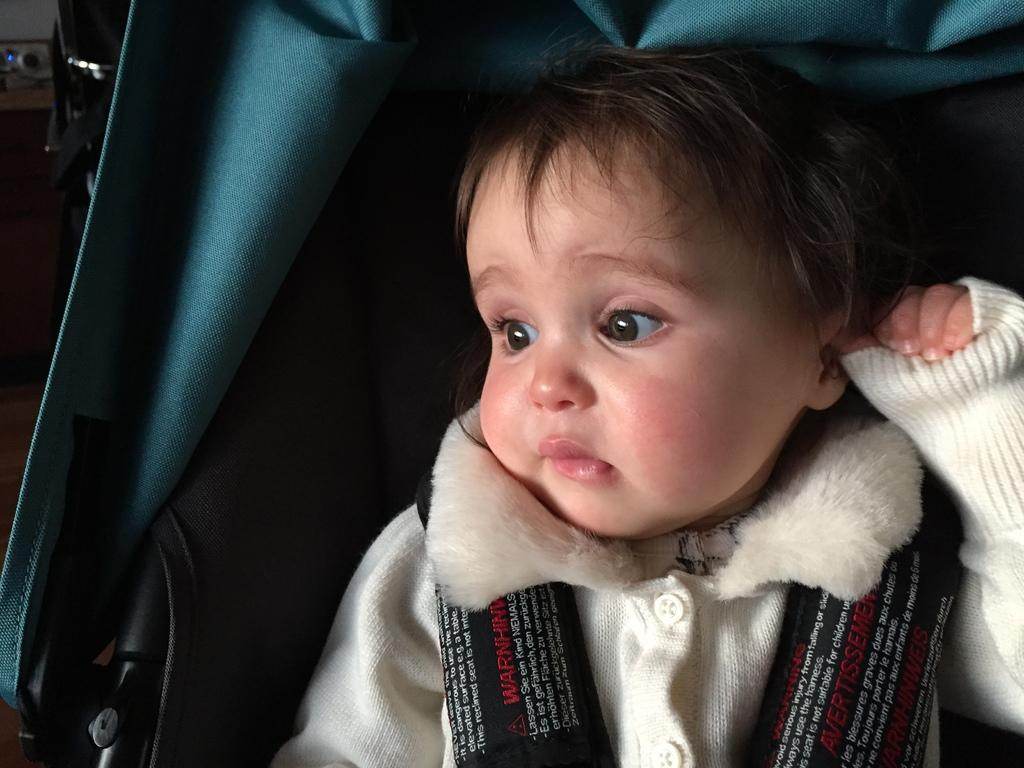What is the main subject of the image? There is a baby in the image. What is the baby wearing? The baby is wearing a white jacket. What is the baby sitting on? The baby is sitting on a black and blue colored surface. What type of accessory is the baby wearing? There are black belts on the baby. What type of lift is the baby using to sail under the bridge in the image? There is no lift or bridge present in the image; it features a baby sitting on a black and blue colored surface. What type of underwear is the baby wearing under the white jacket? There is no information about the baby's underwear in the image. 